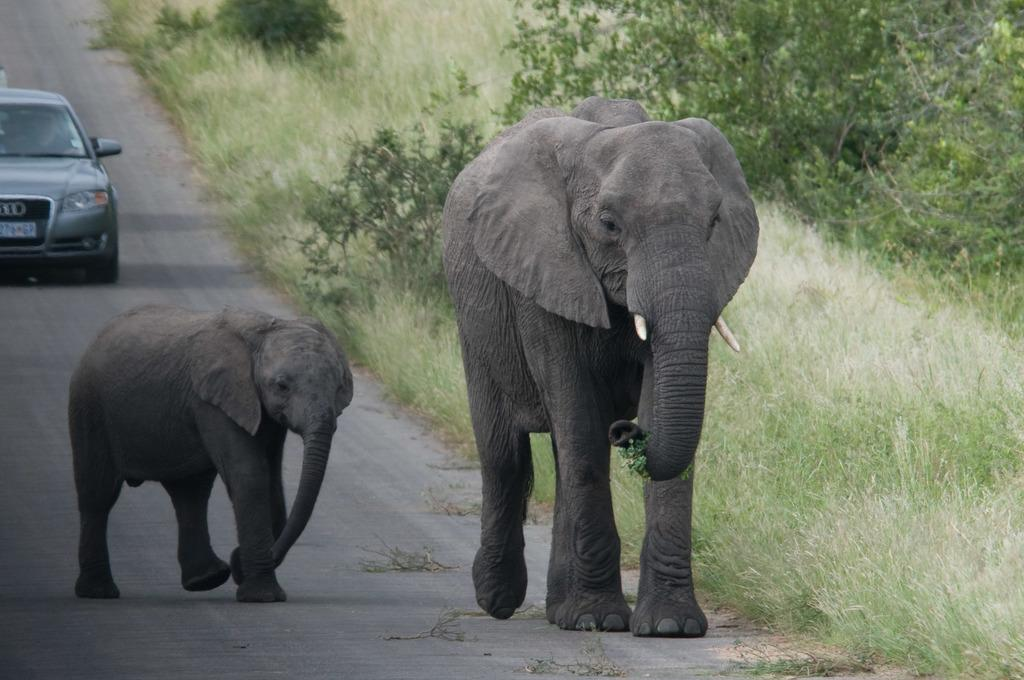What type of animal can be seen in the image? There is an elephant and a baby elephant in the image. What are the elephants doing in the image? The elephants are walking on the road. What type of vegetation is visible in the image? There is grass, trees, and plants visible in the image. Is there any other object or vehicle on the road in the image? Yes, there is a car on the road in the image. What time of day is it in the image, considering the presence of ants? There are no ants present in the image, so it is not possible to determine the time of day based on their presence. 